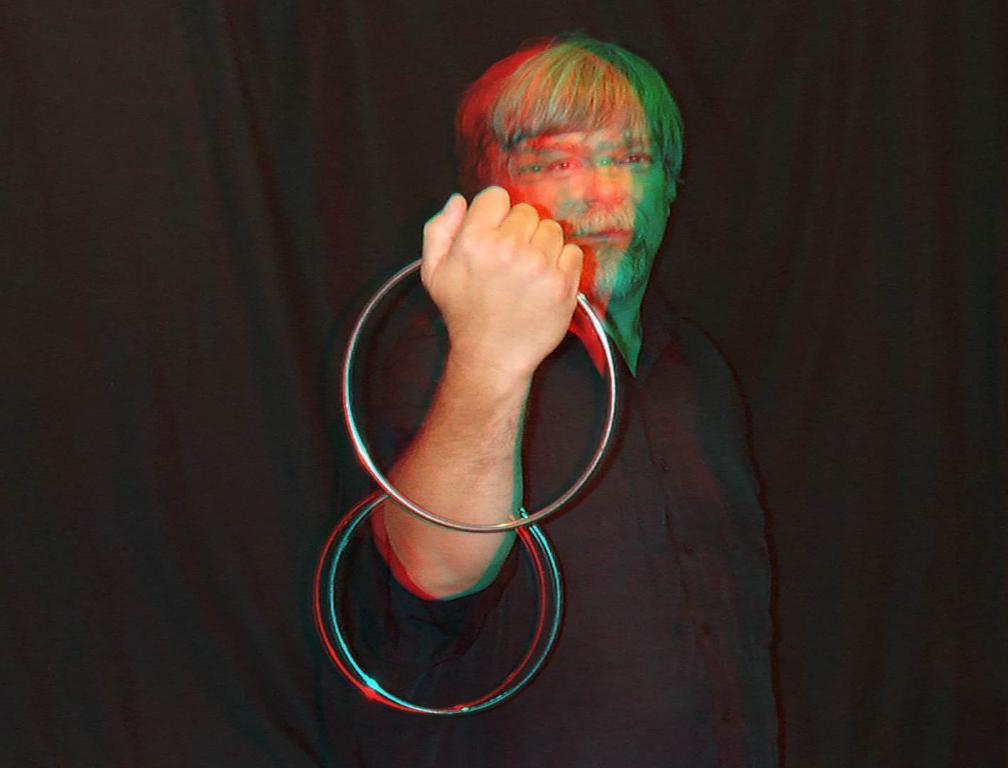Describe this image in one or two sentences. In this image we can see a person holding metal rings and a dark background. 